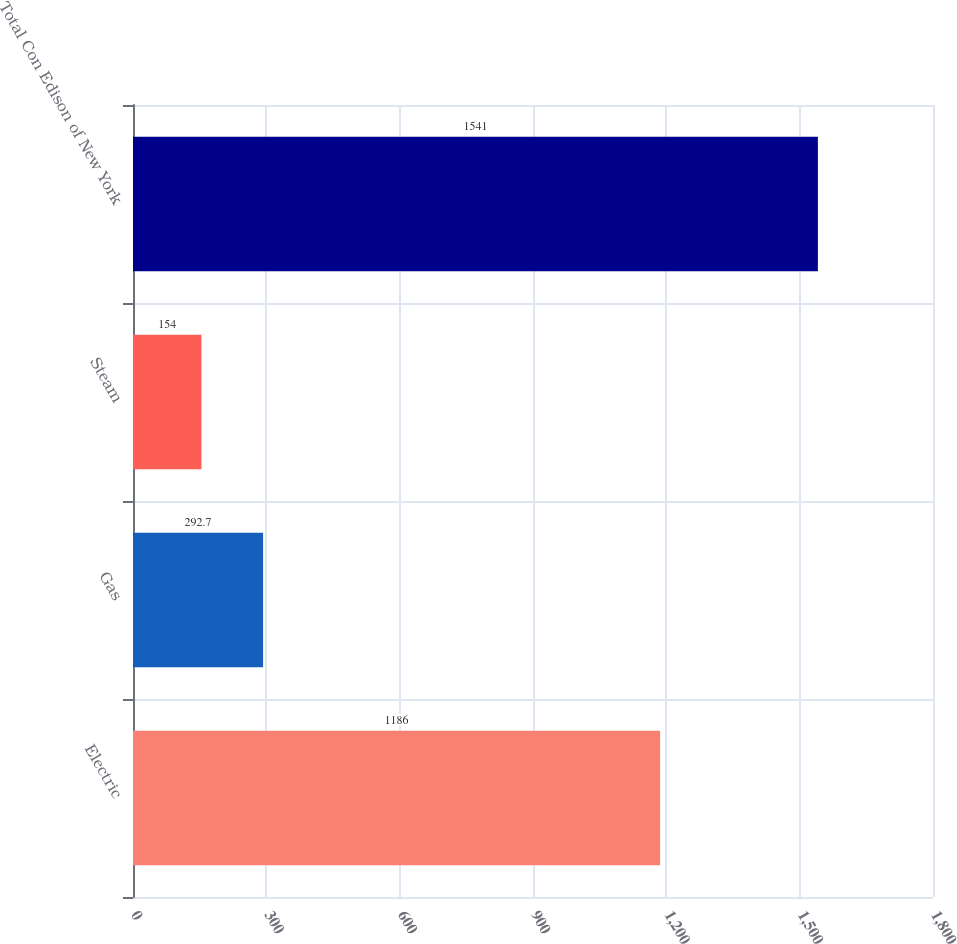Convert chart. <chart><loc_0><loc_0><loc_500><loc_500><bar_chart><fcel>Electric<fcel>Gas<fcel>Steam<fcel>Total Con Edison of New York<nl><fcel>1186<fcel>292.7<fcel>154<fcel>1541<nl></chart> 